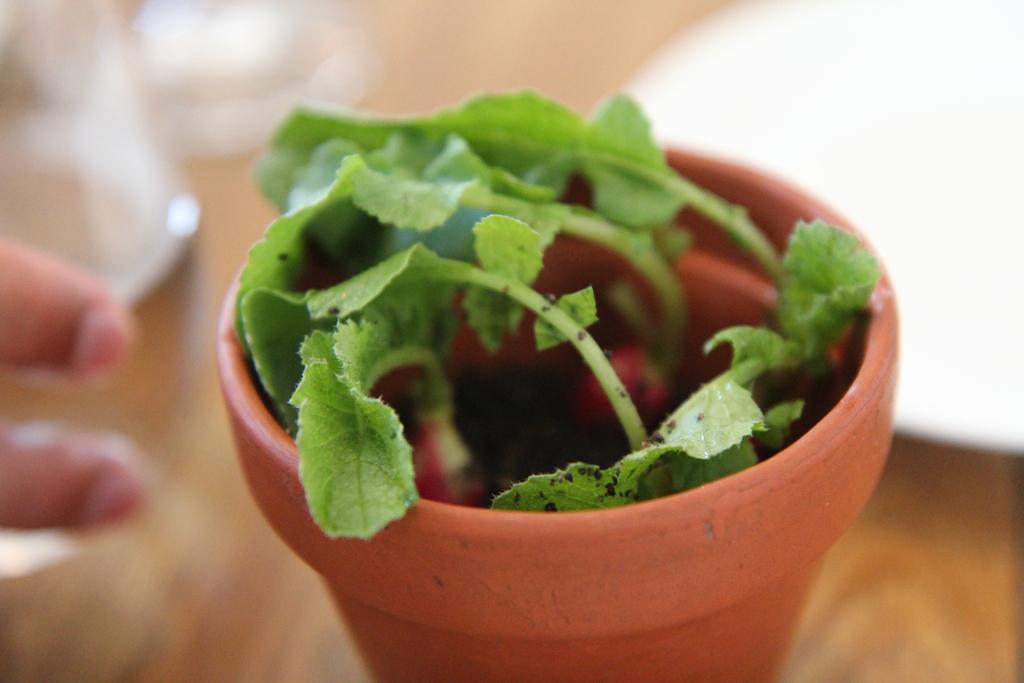Can you describe this image briefly? In this image there is a plant pot, beside the plant pot we can see the fingers of a person. 